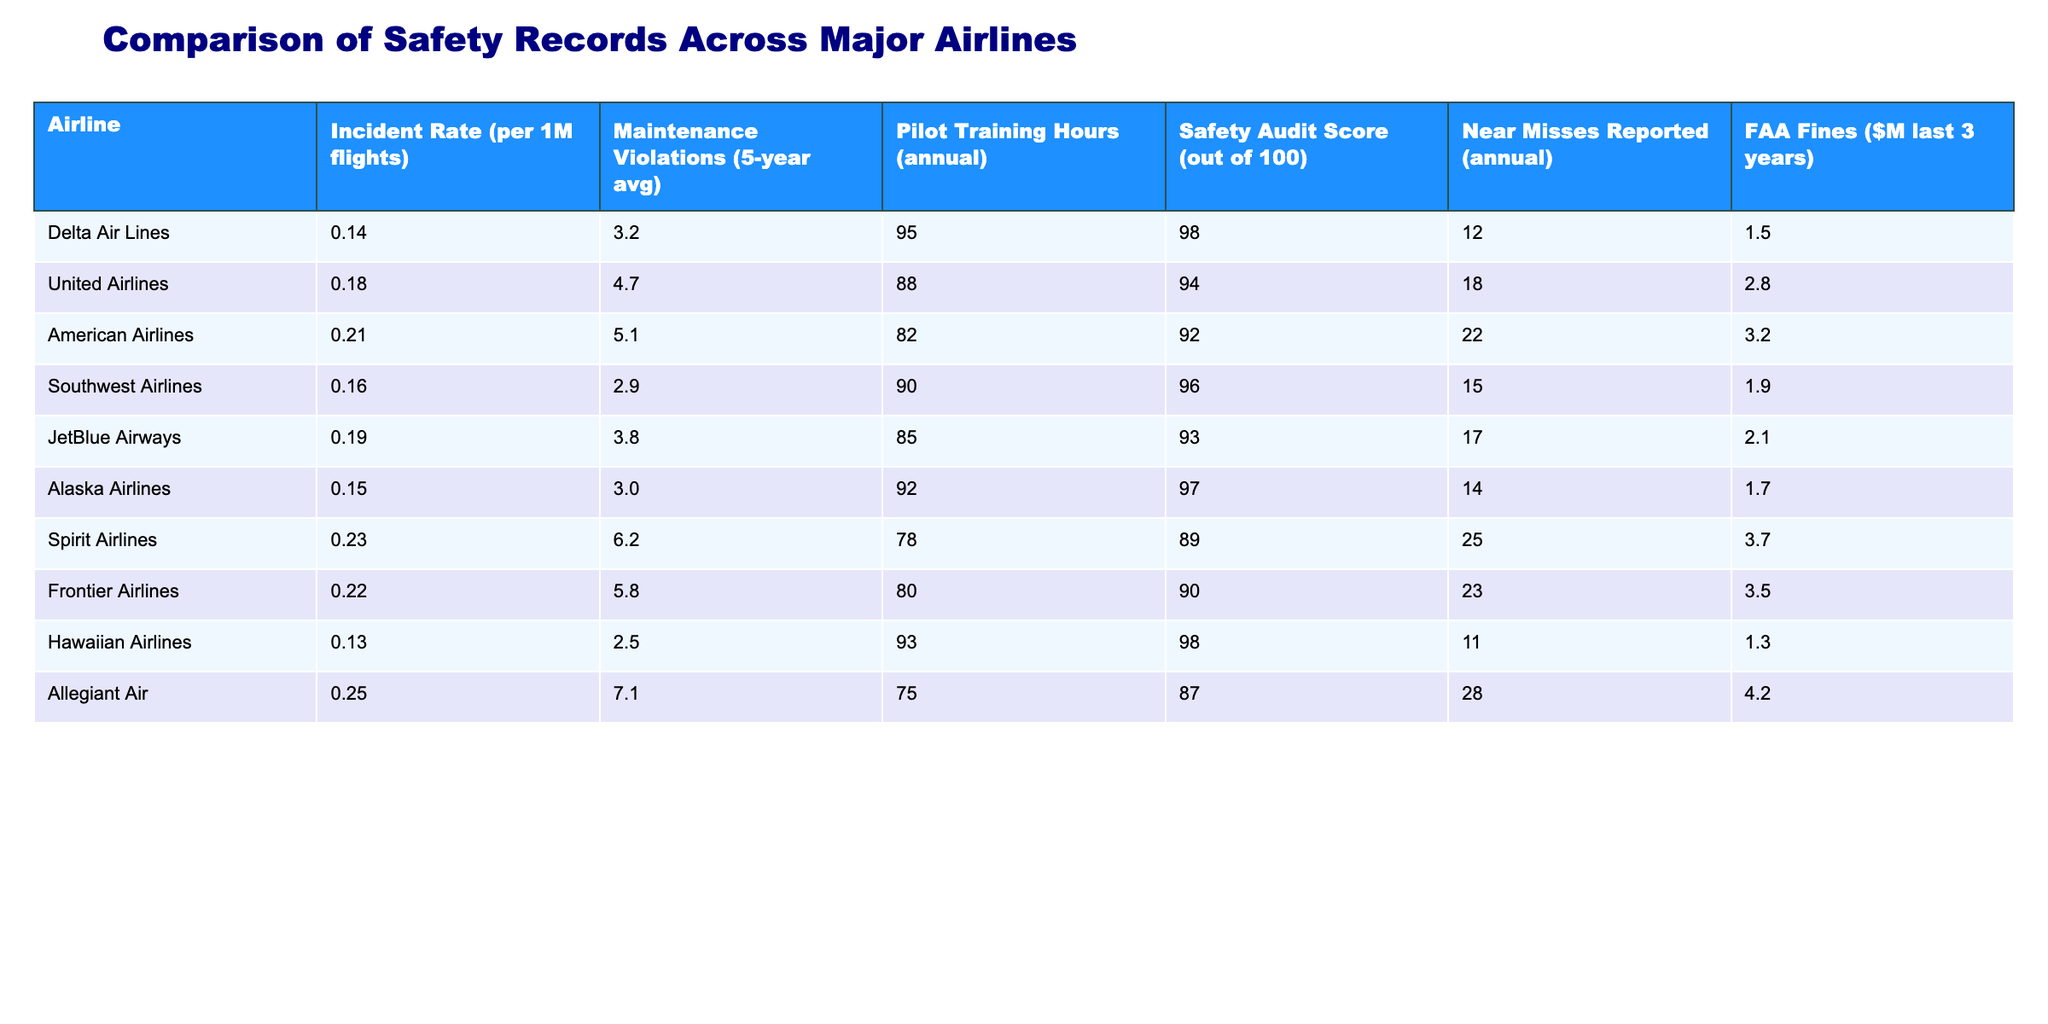What is the incident rate for Delta Air Lines? The incident rate is explicitly provided in the table as 0.14 per 1 million flights for Delta Air Lines.
Answer: 0.14 Which airline has the highest maintenance violations on average over the last five years? By comparing the maintenance violation values for each airline, Allegiant Air has the highest average with a value of 7.1.
Answer: Allegiant Air What is the average pilot training hours for the airlines listed? To find the average, add the pilot training hours: (95 + 88 + 82 + 90 + 85 + 92 + 78 + 80 + 93 + 75) = 900. Then, divide by the number of airlines (10): 900/10 = 90.
Answer: 90 Is the safety audit score for Southwest Airlines higher than that of Spirit Airlines? The safety audit score for Southwest Airlines is 96, while Spirit Airlines has a score of 89. Since 96 is greater than 89, the answer is yes.
Answer: Yes What is the total number of near misses reported by American Airlines and Spirit Airlines combined? American Airlines reports 22 near misses and Spirit Airlines reports 25 near misses. Adding these values gives 22 + 25 = 47.
Answer: 47 Which airline has both the highest FAA fines and the highest incident rate? From the table, Allegiant Air has the highest FAA fines at 4.2 million dollars, and it also has the highest incident rate of 0.25 per million flights. Therefore, it meets both criteria.
Answer: Allegiant Air If you rank the airlines by safety audit score, which airline is in the fourth position? Listing the airlines by safety audit score in descending order gives: Delta Air Lines (98), Hawaiian Airlines (98), Alaska Airlines (97), and Southwest Airlines (96). The fourth position is Southwest Airlines.
Answer: Southwest Airlines Which airline has the lowest maintenance violations and what is that value? By reviewing the maintenance violation data, Hawaiian Airlines has the lowest average maintenance violations at 2.5.
Answer: Hawaiian Airlines, 2.5 Is JetBlue Airways safer than American Airlines based on the incident rate? JetBlue Airways has an incident rate of 0.19, while American Airlines has an incident rate of 0.21. Since 0.19 (JetBlue) is lower than 0.21 (American), it is indeed safer in terms of incident rate.
Answer: Yes 